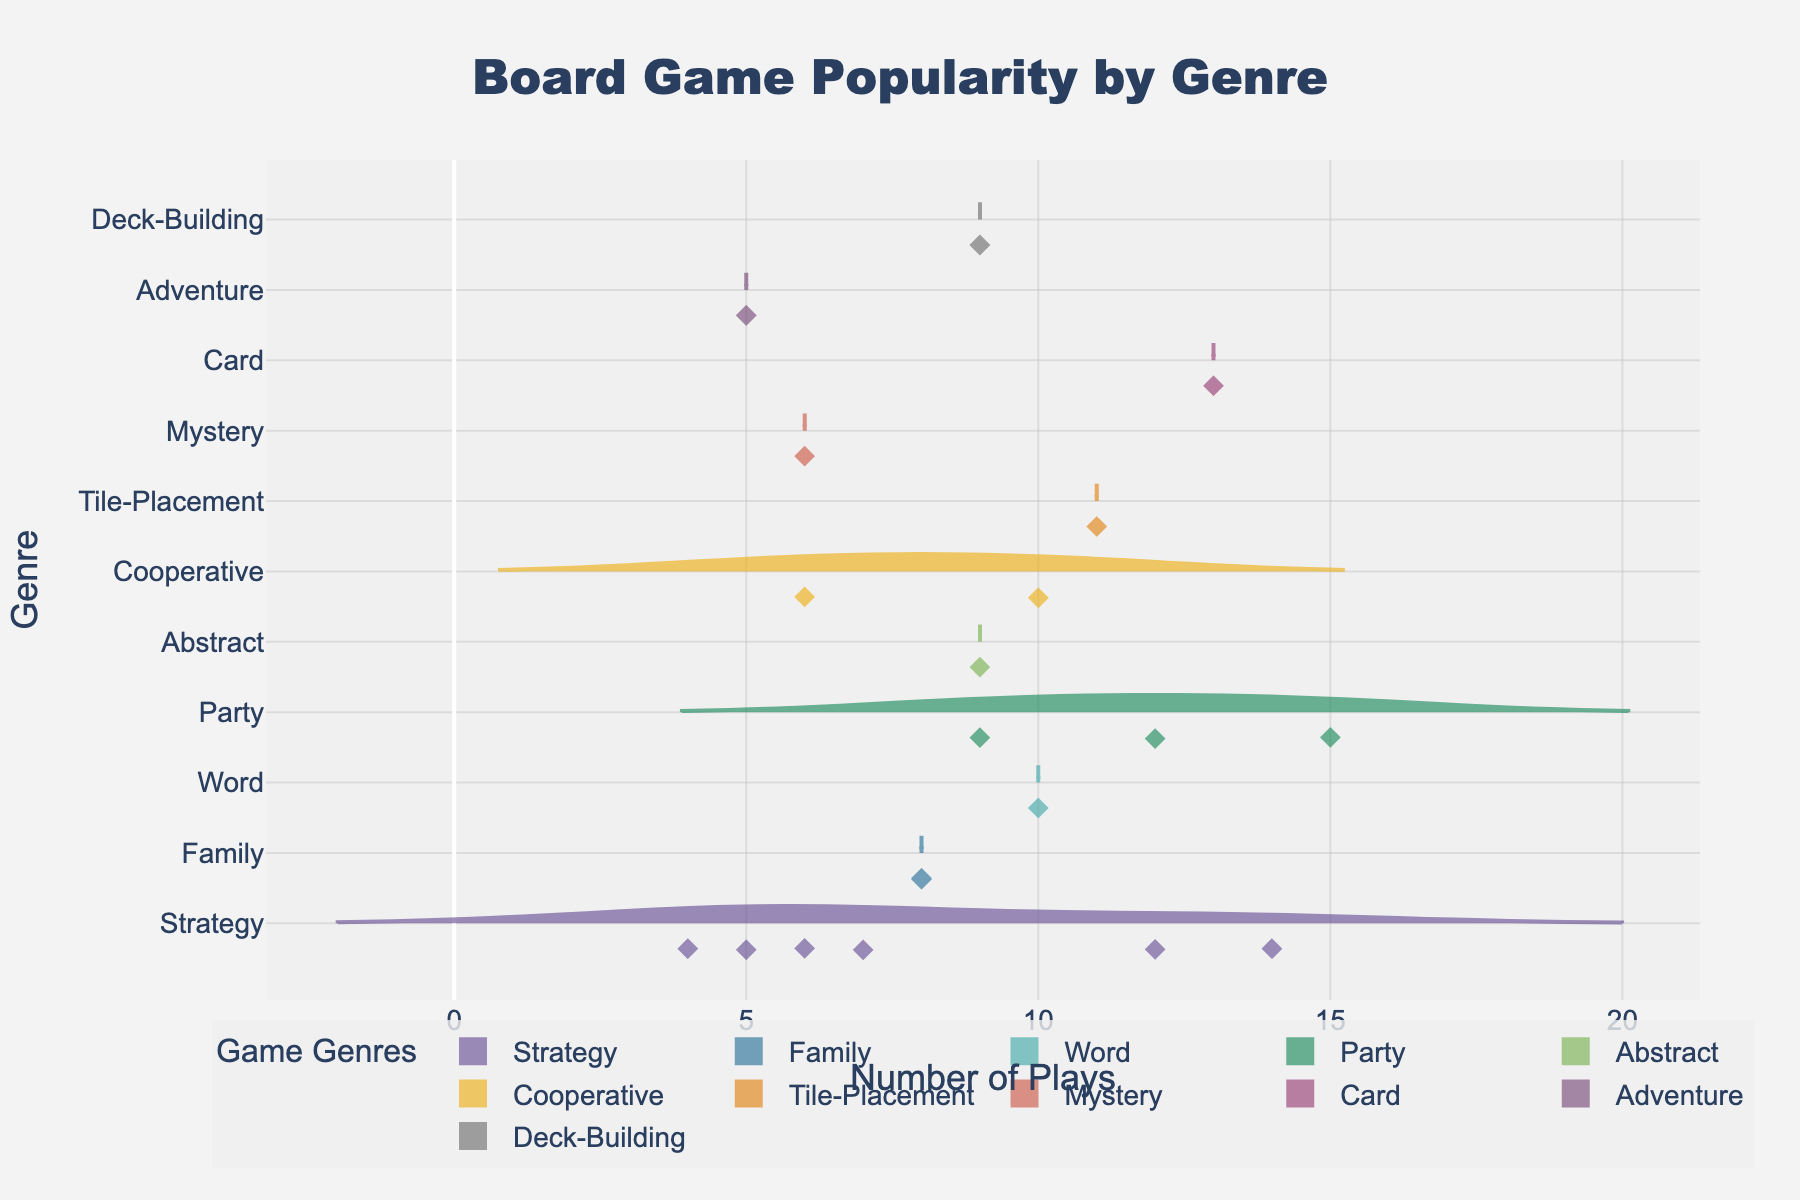Which genre of board games has the highest average number of plays? First, locate the mean line on each violin plot to find the average. The mean line for Party games appears to be highest among the genres.
Answer: Party What is the range of plays for Strategy games? Identify the minimum and maximum data points within the Strategy genre's violin plot. From the plot, the minimum is 4 and the maximum is 14, so the range is 14 - 4.
Answer: 10 Which genre has the least variability in the number of plays? Look at the width of each violin plot, which indicates the spread of data. The Cooperative games have the narrowest plot, implying the least variability.
Answer: Cooperative How many genres have games played more than 10 times? Count the number of distinct genres where the maximum number of plays goes beyond 10. Party, Card, and Strategy genres have maximum plays above 10.
Answer: Three Which genre shows the most number of board games with the exact same number of plays? Observe where data points are concentrated. The Strategy genre shows multiple peaks, indicating several games with the same play numbers (specifically clustered around lower and middle values).
Answer: Strategy Is there more variation in the number of plays for Abstract games compared to Cooperative games? Compare the width of the violin plots for Abstract and Cooperative genres. The plot for Abstract is wider, indicating more variation than Cooperative.
Answer: Yes Which genre has the most outliers in terms of the number of plays? Outliers are marked in the plot. Strategy has the most distinct points spread from the median line, indicating a higher number of outliers.
Answer: Strategy What is the median number of plays for Family games? Find the median line within the Family genre's violin plot. The median for Family games appears roughly around 8 plays.
Answer: 8 Do Party games have any outliers? Examine the Party genre's plot for any diamond-shaped markers outside the main distribution. There are a few outliers above the central data concentration in the Party genre.
Answer: Yes Are there any genres where no game has been played fewer than 6 times? Check the lower ends of the violin plots for all genres. Card games and Word games do not go below 6 plays.
Answer: Two genres (Card and Word) 